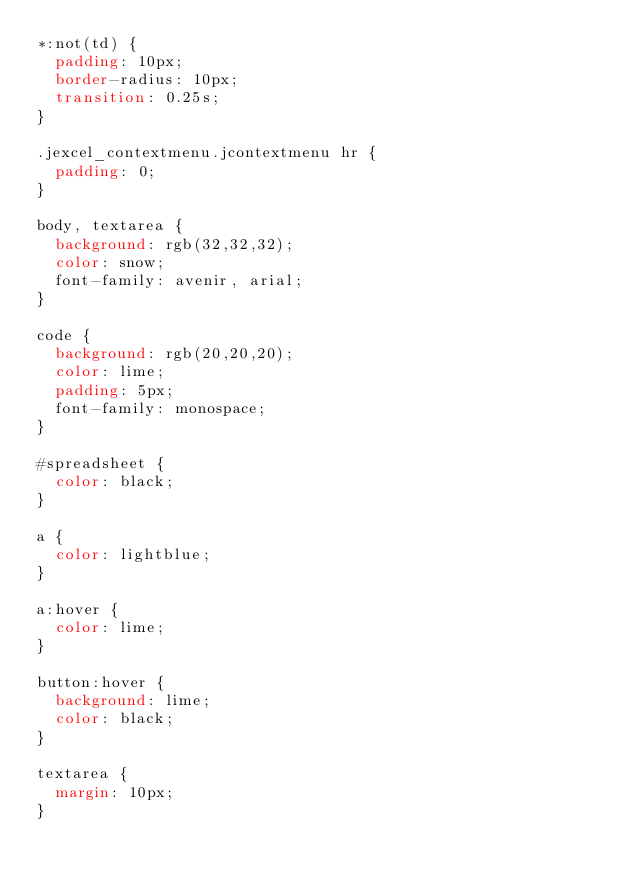Convert code to text. <code><loc_0><loc_0><loc_500><loc_500><_CSS_>*:not(td) {
  padding: 10px;
  border-radius: 10px;
  transition: 0.25s;
}

.jexcel_contextmenu.jcontextmenu hr {
  padding: 0;
}

body, textarea {
  background: rgb(32,32,32);
  color: snow;
  font-family: avenir, arial;
}

code {
  background: rgb(20,20,20);
  color: lime;
  padding: 5px;
  font-family: monospace;
}

#spreadsheet {
  color: black;
}

a {
  color: lightblue;
}

a:hover {
  color: lime;
}

button:hover {
  background: lime;
  color: black;
}

textarea {
  margin: 10px;
}
</code> 